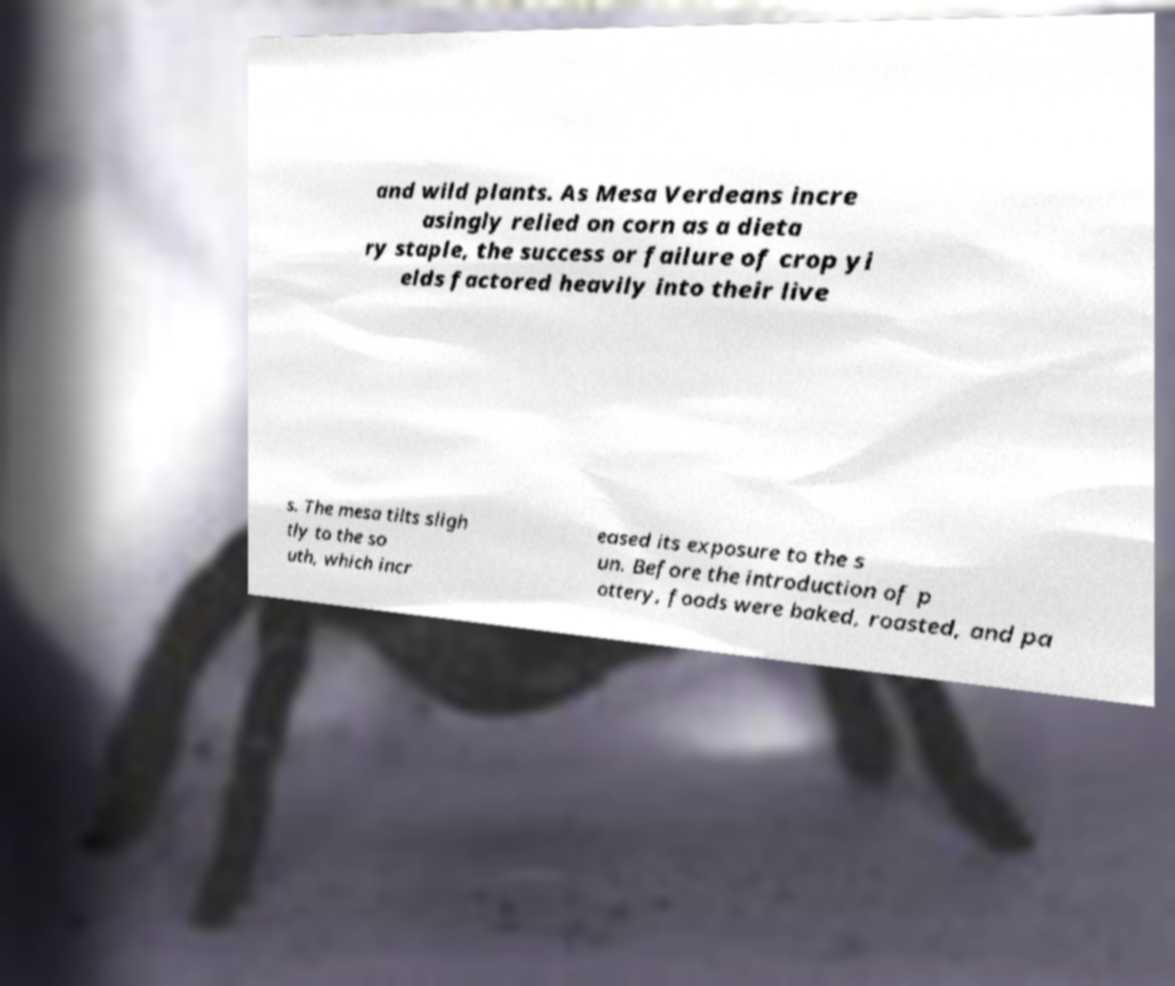There's text embedded in this image that I need extracted. Can you transcribe it verbatim? and wild plants. As Mesa Verdeans incre asingly relied on corn as a dieta ry staple, the success or failure of crop yi elds factored heavily into their live s. The mesa tilts sligh tly to the so uth, which incr eased its exposure to the s un. Before the introduction of p ottery, foods were baked, roasted, and pa 